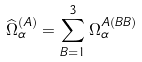Convert formula to latex. <formula><loc_0><loc_0><loc_500><loc_500>\widehat { \Omega } _ { \alpha } ^ { ( A ) } = \sum _ { B = 1 } ^ { 3 } \Omega _ { \alpha } ^ { A ( B B ) }</formula> 